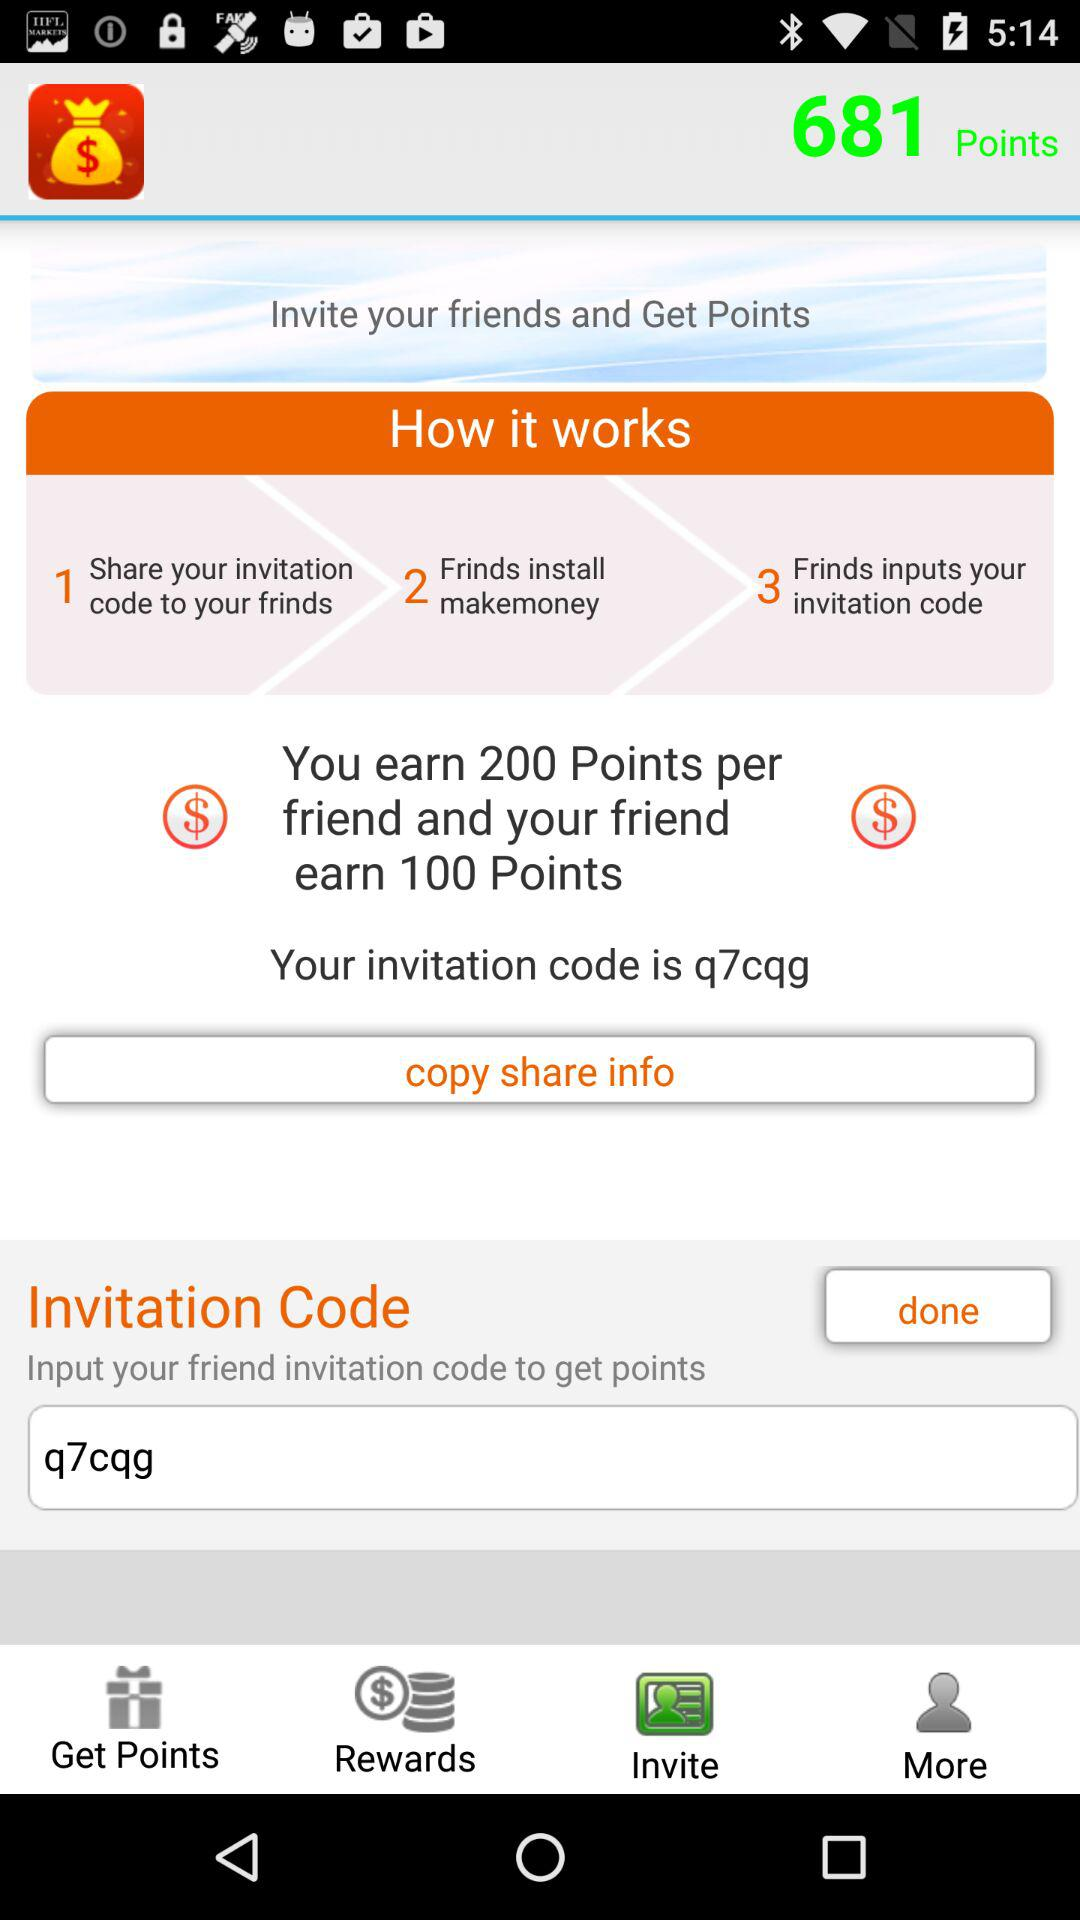How many points do I earn if my friend invites 2 friends?
Answer the question using a single word or phrase. 400 